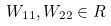Convert formula to latex. <formula><loc_0><loc_0><loc_500><loc_500>W _ { 1 1 } , W _ { 2 2 } \in R</formula> 